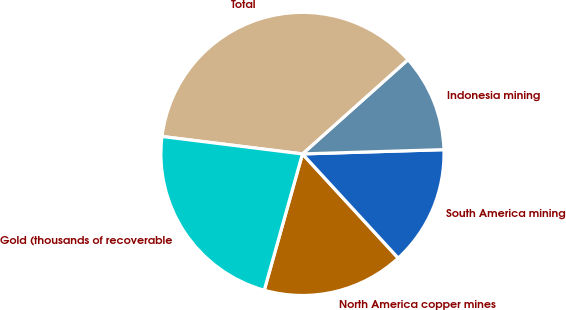Convert chart. <chart><loc_0><loc_0><loc_500><loc_500><pie_chart><fcel>North America copper mines<fcel>South America mining<fcel>Indonesia mining<fcel>Total<fcel>Gold (thousands of recoverable<nl><fcel>16.18%<fcel>13.65%<fcel>11.12%<fcel>36.43%<fcel>22.62%<nl></chart> 